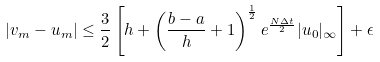<formula> <loc_0><loc_0><loc_500><loc_500>| v _ { m } - u _ { m } | \leq \frac { 3 } { 2 } \left [ h + \left ( \frac { b - a } { h } + 1 \right ) ^ { \frac { 1 } { 2 } } e ^ { \frac { N \Delta t } { 2 } } | u _ { 0 } | _ { \infty } \right ] + \epsilon</formula> 